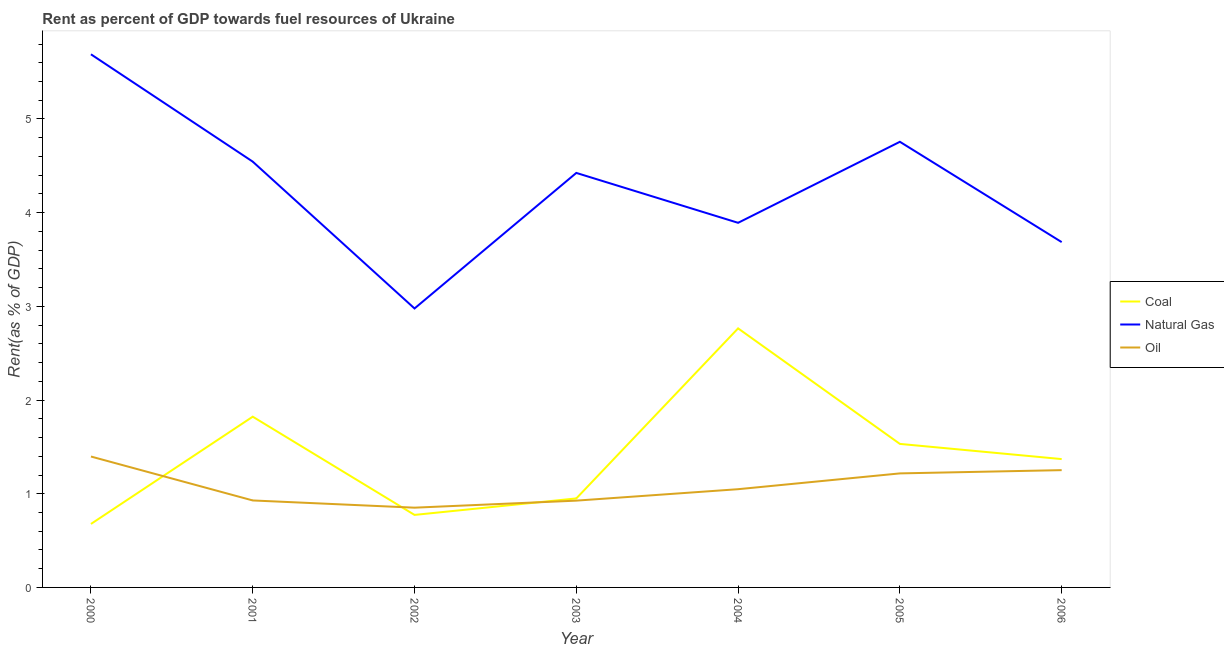How many different coloured lines are there?
Offer a terse response. 3. Does the line corresponding to rent towards coal intersect with the line corresponding to rent towards oil?
Make the answer very short. Yes. Is the number of lines equal to the number of legend labels?
Your answer should be compact. Yes. What is the rent towards oil in 2004?
Offer a very short reply. 1.05. Across all years, what is the maximum rent towards coal?
Your response must be concise. 2.77. Across all years, what is the minimum rent towards natural gas?
Offer a terse response. 2.98. In which year was the rent towards natural gas maximum?
Ensure brevity in your answer.  2000. In which year was the rent towards coal minimum?
Your response must be concise. 2000. What is the total rent towards coal in the graph?
Offer a terse response. 9.89. What is the difference between the rent towards oil in 2001 and that in 2003?
Ensure brevity in your answer.  0. What is the difference between the rent towards natural gas in 2005 and the rent towards coal in 2001?
Give a very brief answer. 2.93. What is the average rent towards coal per year?
Your response must be concise. 1.41. In the year 2004, what is the difference between the rent towards oil and rent towards natural gas?
Provide a succinct answer. -2.84. In how many years, is the rent towards oil greater than 2 %?
Your answer should be compact. 0. What is the ratio of the rent towards coal in 2002 to that in 2003?
Offer a terse response. 0.81. Is the rent towards oil in 2001 less than that in 2003?
Make the answer very short. No. What is the difference between the highest and the second highest rent towards coal?
Your response must be concise. 0.94. What is the difference between the highest and the lowest rent towards natural gas?
Ensure brevity in your answer.  2.71. Is the sum of the rent towards oil in 2004 and 2006 greater than the maximum rent towards natural gas across all years?
Give a very brief answer. No. Is the rent towards coal strictly greater than the rent towards natural gas over the years?
Ensure brevity in your answer.  No. Is the rent towards oil strictly less than the rent towards coal over the years?
Provide a succinct answer. No. What is the difference between two consecutive major ticks on the Y-axis?
Give a very brief answer. 1. Does the graph contain any zero values?
Ensure brevity in your answer.  No. Does the graph contain grids?
Your answer should be compact. No. Where does the legend appear in the graph?
Ensure brevity in your answer.  Center right. How many legend labels are there?
Offer a terse response. 3. What is the title of the graph?
Offer a very short reply. Rent as percent of GDP towards fuel resources of Ukraine. What is the label or title of the Y-axis?
Provide a short and direct response. Rent(as % of GDP). What is the Rent(as % of GDP) in Coal in 2000?
Provide a short and direct response. 0.68. What is the Rent(as % of GDP) in Natural Gas in 2000?
Offer a terse response. 5.69. What is the Rent(as % of GDP) of Oil in 2000?
Give a very brief answer. 1.4. What is the Rent(as % of GDP) in Coal in 2001?
Provide a succinct answer. 1.82. What is the Rent(as % of GDP) of Natural Gas in 2001?
Your answer should be very brief. 4.54. What is the Rent(as % of GDP) in Oil in 2001?
Provide a succinct answer. 0.93. What is the Rent(as % of GDP) in Coal in 2002?
Your response must be concise. 0.77. What is the Rent(as % of GDP) of Natural Gas in 2002?
Provide a short and direct response. 2.98. What is the Rent(as % of GDP) of Oil in 2002?
Make the answer very short. 0.85. What is the Rent(as % of GDP) of Coal in 2003?
Make the answer very short. 0.95. What is the Rent(as % of GDP) in Natural Gas in 2003?
Ensure brevity in your answer.  4.42. What is the Rent(as % of GDP) in Oil in 2003?
Offer a terse response. 0.93. What is the Rent(as % of GDP) of Coal in 2004?
Provide a succinct answer. 2.77. What is the Rent(as % of GDP) in Natural Gas in 2004?
Your answer should be compact. 3.89. What is the Rent(as % of GDP) of Oil in 2004?
Make the answer very short. 1.05. What is the Rent(as % of GDP) in Coal in 2005?
Your answer should be compact. 1.53. What is the Rent(as % of GDP) of Natural Gas in 2005?
Your answer should be compact. 4.76. What is the Rent(as % of GDP) of Oil in 2005?
Provide a succinct answer. 1.22. What is the Rent(as % of GDP) of Coal in 2006?
Your answer should be compact. 1.37. What is the Rent(as % of GDP) of Natural Gas in 2006?
Offer a very short reply. 3.69. What is the Rent(as % of GDP) of Oil in 2006?
Your answer should be compact. 1.25. Across all years, what is the maximum Rent(as % of GDP) of Coal?
Offer a terse response. 2.77. Across all years, what is the maximum Rent(as % of GDP) of Natural Gas?
Give a very brief answer. 5.69. Across all years, what is the maximum Rent(as % of GDP) of Oil?
Your response must be concise. 1.4. Across all years, what is the minimum Rent(as % of GDP) in Coal?
Offer a very short reply. 0.68. Across all years, what is the minimum Rent(as % of GDP) in Natural Gas?
Your answer should be compact. 2.98. Across all years, what is the minimum Rent(as % of GDP) in Oil?
Keep it short and to the point. 0.85. What is the total Rent(as % of GDP) of Coal in the graph?
Your answer should be compact. 9.89. What is the total Rent(as % of GDP) in Natural Gas in the graph?
Provide a succinct answer. 29.97. What is the total Rent(as % of GDP) in Oil in the graph?
Ensure brevity in your answer.  7.62. What is the difference between the Rent(as % of GDP) in Coal in 2000 and that in 2001?
Make the answer very short. -1.15. What is the difference between the Rent(as % of GDP) of Natural Gas in 2000 and that in 2001?
Your answer should be compact. 1.15. What is the difference between the Rent(as % of GDP) in Oil in 2000 and that in 2001?
Offer a very short reply. 0.47. What is the difference between the Rent(as % of GDP) in Coal in 2000 and that in 2002?
Keep it short and to the point. -0.1. What is the difference between the Rent(as % of GDP) in Natural Gas in 2000 and that in 2002?
Your answer should be very brief. 2.71. What is the difference between the Rent(as % of GDP) of Oil in 2000 and that in 2002?
Keep it short and to the point. 0.55. What is the difference between the Rent(as % of GDP) in Coal in 2000 and that in 2003?
Ensure brevity in your answer.  -0.27. What is the difference between the Rent(as % of GDP) in Natural Gas in 2000 and that in 2003?
Provide a succinct answer. 1.27. What is the difference between the Rent(as % of GDP) of Oil in 2000 and that in 2003?
Keep it short and to the point. 0.47. What is the difference between the Rent(as % of GDP) in Coal in 2000 and that in 2004?
Make the answer very short. -2.09. What is the difference between the Rent(as % of GDP) in Natural Gas in 2000 and that in 2004?
Give a very brief answer. 1.8. What is the difference between the Rent(as % of GDP) of Oil in 2000 and that in 2004?
Your answer should be very brief. 0.35. What is the difference between the Rent(as % of GDP) of Coal in 2000 and that in 2005?
Your answer should be compact. -0.85. What is the difference between the Rent(as % of GDP) of Natural Gas in 2000 and that in 2005?
Your answer should be compact. 0.93. What is the difference between the Rent(as % of GDP) in Oil in 2000 and that in 2005?
Offer a terse response. 0.18. What is the difference between the Rent(as % of GDP) in Coal in 2000 and that in 2006?
Your answer should be compact. -0.69. What is the difference between the Rent(as % of GDP) in Natural Gas in 2000 and that in 2006?
Offer a terse response. 2. What is the difference between the Rent(as % of GDP) of Oil in 2000 and that in 2006?
Offer a terse response. 0.15. What is the difference between the Rent(as % of GDP) of Coal in 2001 and that in 2002?
Ensure brevity in your answer.  1.05. What is the difference between the Rent(as % of GDP) in Natural Gas in 2001 and that in 2002?
Your answer should be compact. 1.57. What is the difference between the Rent(as % of GDP) of Oil in 2001 and that in 2002?
Offer a terse response. 0.08. What is the difference between the Rent(as % of GDP) in Coal in 2001 and that in 2003?
Make the answer very short. 0.87. What is the difference between the Rent(as % of GDP) in Natural Gas in 2001 and that in 2003?
Your response must be concise. 0.12. What is the difference between the Rent(as % of GDP) of Oil in 2001 and that in 2003?
Ensure brevity in your answer.  0. What is the difference between the Rent(as % of GDP) of Coal in 2001 and that in 2004?
Provide a short and direct response. -0.94. What is the difference between the Rent(as % of GDP) of Natural Gas in 2001 and that in 2004?
Offer a very short reply. 0.65. What is the difference between the Rent(as % of GDP) in Oil in 2001 and that in 2004?
Give a very brief answer. -0.12. What is the difference between the Rent(as % of GDP) in Coal in 2001 and that in 2005?
Your answer should be very brief. 0.29. What is the difference between the Rent(as % of GDP) in Natural Gas in 2001 and that in 2005?
Your answer should be very brief. -0.21. What is the difference between the Rent(as % of GDP) in Oil in 2001 and that in 2005?
Offer a terse response. -0.29. What is the difference between the Rent(as % of GDP) in Coal in 2001 and that in 2006?
Your response must be concise. 0.45. What is the difference between the Rent(as % of GDP) in Natural Gas in 2001 and that in 2006?
Keep it short and to the point. 0.86. What is the difference between the Rent(as % of GDP) of Oil in 2001 and that in 2006?
Give a very brief answer. -0.32. What is the difference between the Rent(as % of GDP) in Coal in 2002 and that in 2003?
Provide a succinct answer. -0.18. What is the difference between the Rent(as % of GDP) of Natural Gas in 2002 and that in 2003?
Provide a short and direct response. -1.45. What is the difference between the Rent(as % of GDP) of Oil in 2002 and that in 2003?
Your response must be concise. -0.08. What is the difference between the Rent(as % of GDP) in Coal in 2002 and that in 2004?
Your answer should be very brief. -1.99. What is the difference between the Rent(as % of GDP) in Natural Gas in 2002 and that in 2004?
Provide a short and direct response. -0.91. What is the difference between the Rent(as % of GDP) of Oil in 2002 and that in 2004?
Your answer should be compact. -0.2. What is the difference between the Rent(as % of GDP) in Coal in 2002 and that in 2005?
Ensure brevity in your answer.  -0.76. What is the difference between the Rent(as % of GDP) in Natural Gas in 2002 and that in 2005?
Your answer should be compact. -1.78. What is the difference between the Rent(as % of GDP) in Oil in 2002 and that in 2005?
Your answer should be very brief. -0.37. What is the difference between the Rent(as % of GDP) of Coal in 2002 and that in 2006?
Your response must be concise. -0.6. What is the difference between the Rent(as % of GDP) of Natural Gas in 2002 and that in 2006?
Your answer should be very brief. -0.71. What is the difference between the Rent(as % of GDP) in Oil in 2002 and that in 2006?
Give a very brief answer. -0.4. What is the difference between the Rent(as % of GDP) of Coal in 2003 and that in 2004?
Provide a succinct answer. -1.81. What is the difference between the Rent(as % of GDP) in Natural Gas in 2003 and that in 2004?
Your answer should be very brief. 0.53. What is the difference between the Rent(as % of GDP) in Oil in 2003 and that in 2004?
Offer a terse response. -0.12. What is the difference between the Rent(as % of GDP) of Coal in 2003 and that in 2005?
Your answer should be very brief. -0.58. What is the difference between the Rent(as % of GDP) in Natural Gas in 2003 and that in 2005?
Keep it short and to the point. -0.33. What is the difference between the Rent(as % of GDP) in Oil in 2003 and that in 2005?
Provide a succinct answer. -0.29. What is the difference between the Rent(as % of GDP) in Coal in 2003 and that in 2006?
Offer a terse response. -0.42. What is the difference between the Rent(as % of GDP) in Natural Gas in 2003 and that in 2006?
Your response must be concise. 0.74. What is the difference between the Rent(as % of GDP) of Oil in 2003 and that in 2006?
Provide a short and direct response. -0.33. What is the difference between the Rent(as % of GDP) in Coal in 2004 and that in 2005?
Make the answer very short. 1.23. What is the difference between the Rent(as % of GDP) of Natural Gas in 2004 and that in 2005?
Offer a terse response. -0.86. What is the difference between the Rent(as % of GDP) in Oil in 2004 and that in 2005?
Your answer should be very brief. -0.17. What is the difference between the Rent(as % of GDP) of Coal in 2004 and that in 2006?
Ensure brevity in your answer.  1.4. What is the difference between the Rent(as % of GDP) of Natural Gas in 2004 and that in 2006?
Provide a succinct answer. 0.21. What is the difference between the Rent(as % of GDP) of Oil in 2004 and that in 2006?
Offer a very short reply. -0.2. What is the difference between the Rent(as % of GDP) of Coal in 2005 and that in 2006?
Offer a terse response. 0.16. What is the difference between the Rent(as % of GDP) in Natural Gas in 2005 and that in 2006?
Your response must be concise. 1.07. What is the difference between the Rent(as % of GDP) in Oil in 2005 and that in 2006?
Provide a succinct answer. -0.03. What is the difference between the Rent(as % of GDP) in Coal in 2000 and the Rent(as % of GDP) in Natural Gas in 2001?
Your answer should be very brief. -3.87. What is the difference between the Rent(as % of GDP) in Coal in 2000 and the Rent(as % of GDP) in Oil in 2001?
Your answer should be compact. -0.25. What is the difference between the Rent(as % of GDP) of Natural Gas in 2000 and the Rent(as % of GDP) of Oil in 2001?
Your answer should be compact. 4.76. What is the difference between the Rent(as % of GDP) in Coal in 2000 and the Rent(as % of GDP) in Natural Gas in 2002?
Your answer should be very brief. -2.3. What is the difference between the Rent(as % of GDP) of Coal in 2000 and the Rent(as % of GDP) of Oil in 2002?
Provide a succinct answer. -0.17. What is the difference between the Rent(as % of GDP) of Natural Gas in 2000 and the Rent(as % of GDP) of Oil in 2002?
Ensure brevity in your answer.  4.84. What is the difference between the Rent(as % of GDP) of Coal in 2000 and the Rent(as % of GDP) of Natural Gas in 2003?
Your response must be concise. -3.75. What is the difference between the Rent(as % of GDP) of Coal in 2000 and the Rent(as % of GDP) of Oil in 2003?
Your response must be concise. -0.25. What is the difference between the Rent(as % of GDP) in Natural Gas in 2000 and the Rent(as % of GDP) in Oil in 2003?
Offer a terse response. 4.76. What is the difference between the Rent(as % of GDP) of Coal in 2000 and the Rent(as % of GDP) of Natural Gas in 2004?
Your answer should be very brief. -3.21. What is the difference between the Rent(as % of GDP) of Coal in 2000 and the Rent(as % of GDP) of Oil in 2004?
Keep it short and to the point. -0.37. What is the difference between the Rent(as % of GDP) in Natural Gas in 2000 and the Rent(as % of GDP) in Oil in 2004?
Your answer should be compact. 4.64. What is the difference between the Rent(as % of GDP) in Coal in 2000 and the Rent(as % of GDP) in Natural Gas in 2005?
Make the answer very short. -4.08. What is the difference between the Rent(as % of GDP) of Coal in 2000 and the Rent(as % of GDP) of Oil in 2005?
Make the answer very short. -0.54. What is the difference between the Rent(as % of GDP) of Natural Gas in 2000 and the Rent(as % of GDP) of Oil in 2005?
Provide a succinct answer. 4.47. What is the difference between the Rent(as % of GDP) in Coal in 2000 and the Rent(as % of GDP) in Natural Gas in 2006?
Your response must be concise. -3.01. What is the difference between the Rent(as % of GDP) of Coal in 2000 and the Rent(as % of GDP) of Oil in 2006?
Offer a very short reply. -0.57. What is the difference between the Rent(as % of GDP) of Natural Gas in 2000 and the Rent(as % of GDP) of Oil in 2006?
Give a very brief answer. 4.44. What is the difference between the Rent(as % of GDP) of Coal in 2001 and the Rent(as % of GDP) of Natural Gas in 2002?
Make the answer very short. -1.16. What is the difference between the Rent(as % of GDP) in Coal in 2001 and the Rent(as % of GDP) in Oil in 2002?
Provide a short and direct response. 0.97. What is the difference between the Rent(as % of GDP) of Natural Gas in 2001 and the Rent(as % of GDP) of Oil in 2002?
Your response must be concise. 3.69. What is the difference between the Rent(as % of GDP) of Coal in 2001 and the Rent(as % of GDP) of Natural Gas in 2003?
Your answer should be compact. -2.6. What is the difference between the Rent(as % of GDP) in Coal in 2001 and the Rent(as % of GDP) in Oil in 2003?
Your answer should be compact. 0.9. What is the difference between the Rent(as % of GDP) in Natural Gas in 2001 and the Rent(as % of GDP) in Oil in 2003?
Provide a short and direct response. 3.62. What is the difference between the Rent(as % of GDP) of Coal in 2001 and the Rent(as % of GDP) of Natural Gas in 2004?
Give a very brief answer. -2.07. What is the difference between the Rent(as % of GDP) of Coal in 2001 and the Rent(as % of GDP) of Oil in 2004?
Ensure brevity in your answer.  0.77. What is the difference between the Rent(as % of GDP) in Natural Gas in 2001 and the Rent(as % of GDP) in Oil in 2004?
Offer a terse response. 3.5. What is the difference between the Rent(as % of GDP) of Coal in 2001 and the Rent(as % of GDP) of Natural Gas in 2005?
Offer a very short reply. -2.93. What is the difference between the Rent(as % of GDP) in Coal in 2001 and the Rent(as % of GDP) in Oil in 2005?
Provide a short and direct response. 0.61. What is the difference between the Rent(as % of GDP) in Natural Gas in 2001 and the Rent(as % of GDP) in Oil in 2005?
Provide a short and direct response. 3.33. What is the difference between the Rent(as % of GDP) of Coal in 2001 and the Rent(as % of GDP) of Natural Gas in 2006?
Ensure brevity in your answer.  -1.86. What is the difference between the Rent(as % of GDP) in Coal in 2001 and the Rent(as % of GDP) in Oil in 2006?
Offer a terse response. 0.57. What is the difference between the Rent(as % of GDP) of Natural Gas in 2001 and the Rent(as % of GDP) of Oil in 2006?
Ensure brevity in your answer.  3.29. What is the difference between the Rent(as % of GDP) in Coal in 2002 and the Rent(as % of GDP) in Natural Gas in 2003?
Give a very brief answer. -3.65. What is the difference between the Rent(as % of GDP) in Coal in 2002 and the Rent(as % of GDP) in Oil in 2003?
Offer a terse response. -0.15. What is the difference between the Rent(as % of GDP) of Natural Gas in 2002 and the Rent(as % of GDP) of Oil in 2003?
Your answer should be very brief. 2.05. What is the difference between the Rent(as % of GDP) in Coal in 2002 and the Rent(as % of GDP) in Natural Gas in 2004?
Provide a succinct answer. -3.12. What is the difference between the Rent(as % of GDP) in Coal in 2002 and the Rent(as % of GDP) in Oil in 2004?
Your response must be concise. -0.27. What is the difference between the Rent(as % of GDP) of Natural Gas in 2002 and the Rent(as % of GDP) of Oil in 2004?
Ensure brevity in your answer.  1.93. What is the difference between the Rent(as % of GDP) in Coal in 2002 and the Rent(as % of GDP) in Natural Gas in 2005?
Offer a very short reply. -3.98. What is the difference between the Rent(as % of GDP) in Coal in 2002 and the Rent(as % of GDP) in Oil in 2005?
Your response must be concise. -0.44. What is the difference between the Rent(as % of GDP) of Natural Gas in 2002 and the Rent(as % of GDP) of Oil in 2005?
Offer a very short reply. 1.76. What is the difference between the Rent(as % of GDP) in Coal in 2002 and the Rent(as % of GDP) in Natural Gas in 2006?
Keep it short and to the point. -2.91. What is the difference between the Rent(as % of GDP) in Coal in 2002 and the Rent(as % of GDP) in Oil in 2006?
Keep it short and to the point. -0.48. What is the difference between the Rent(as % of GDP) in Natural Gas in 2002 and the Rent(as % of GDP) in Oil in 2006?
Give a very brief answer. 1.73. What is the difference between the Rent(as % of GDP) of Coal in 2003 and the Rent(as % of GDP) of Natural Gas in 2004?
Offer a terse response. -2.94. What is the difference between the Rent(as % of GDP) in Coal in 2003 and the Rent(as % of GDP) in Oil in 2004?
Provide a short and direct response. -0.1. What is the difference between the Rent(as % of GDP) in Natural Gas in 2003 and the Rent(as % of GDP) in Oil in 2004?
Give a very brief answer. 3.38. What is the difference between the Rent(as % of GDP) of Coal in 2003 and the Rent(as % of GDP) of Natural Gas in 2005?
Your answer should be very brief. -3.81. What is the difference between the Rent(as % of GDP) of Coal in 2003 and the Rent(as % of GDP) of Oil in 2005?
Offer a terse response. -0.27. What is the difference between the Rent(as % of GDP) of Natural Gas in 2003 and the Rent(as % of GDP) of Oil in 2005?
Your answer should be very brief. 3.21. What is the difference between the Rent(as % of GDP) of Coal in 2003 and the Rent(as % of GDP) of Natural Gas in 2006?
Your response must be concise. -2.74. What is the difference between the Rent(as % of GDP) in Coal in 2003 and the Rent(as % of GDP) in Oil in 2006?
Ensure brevity in your answer.  -0.3. What is the difference between the Rent(as % of GDP) of Natural Gas in 2003 and the Rent(as % of GDP) of Oil in 2006?
Your answer should be compact. 3.17. What is the difference between the Rent(as % of GDP) of Coal in 2004 and the Rent(as % of GDP) of Natural Gas in 2005?
Make the answer very short. -1.99. What is the difference between the Rent(as % of GDP) of Coal in 2004 and the Rent(as % of GDP) of Oil in 2005?
Give a very brief answer. 1.55. What is the difference between the Rent(as % of GDP) of Natural Gas in 2004 and the Rent(as % of GDP) of Oil in 2005?
Provide a short and direct response. 2.67. What is the difference between the Rent(as % of GDP) in Coal in 2004 and the Rent(as % of GDP) in Natural Gas in 2006?
Your response must be concise. -0.92. What is the difference between the Rent(as % of GDP) of Coal in 2004 and the Rent(as % of GDP) of Oil in 2006?
Provide a short and direct response. 1.51. What is the difference between the Rent(as % of GDP) in Natural Gas in 2004 and the Rent(as % of GDP) in Oil in 2006?
Make the answer very short. 2.64. What is the difference between the Rent(as % of GDP) in Coal in 2005 and the Rent(as % of GDP) in Natural Gas in 2006?
Ensure brevity in your answer.  -2.15. What is the difference between the Rent(as % of GDP) in Coal in 2005 and the Rent(as % of GDP) in Oil in 2006?
Your answer should be very brief. 0.28. What is the difference between the Rent(as % of GDP) in Natural Gas in 2005 and the Rent(as % of GDP) in Oil in 2006?
Provide a short and direct response. 3.5. What is the average Rent(as % of GDP) of Coal per year?
Your answer should be very brief. 1.41. What is the average Rent(as % of GDP) in Natural Gas per year?
Keep it short and to the point. 4.28. What is the average Rent(as % of GDP) in Oil per year?
Ensure brevity in your answer.  1.09. In the year 2000, what is the difference between the Rent(as % of GDP) in Coal and Rent(as % of GDP) in Natural Gas?
Your response must be concise. -5.01. In the year 2000, what is the difference between the Rent(as % of GDP) in Coal and Rent(as % of GDP) in Oil?
Give a very brief answer. -0.72. In the year 2000, what is the difference between the Rent(as % of GDP) in Natural Gas and Rent(as % of GDP) in Oil?
Provide a short and direct response. 4.29. In the year 2001, what is the difference between the Rent(as % of GDP) of Coal and Rent(as % of GDP) of Natural Gas?
Provide a short and direct response. -2.72. In the year 2001, what is the difference between the Rent(as % of GDP) of Coal and Rent(as % of GDP) of Oil?
Your answer should be compact. 0.89. In the year 2001, what is the difference between the Rent(as % of GDP) in Natural Gas and Rent(as % of GDP) in Oil?
Offer a terse response. 3.62. In the year 2002, what is the difference between the Rent(as % of GDP) in Coal and Rent(as % of GDP) in Natural Gas?
Ensure brevity in your answer.  -2.2. In the year 2002, what is the difference between the Rent(as % of GDP) in Coal and Rent(as % of GDP) in Oil?
Give a very brief answer. -0.08. In the year 2002, what is the difference between the Rent(as % of GDP) in Natural Gas and Rent(as % of GDP) in Oil?
Offer a terse response. 2.13. In the year 2003, what is the difference between the Rent(as % of GDP) in Coal and Rent(as % of GDP) in Natural Gas?
Provide a short and direct response. -3.47. In the year 2003, what is the difference between the Rent(as % of GDP) in Coal and Rent(as % of GDP) in Oil?
Keep it short and to the point. 0.02. In the year 2003, what is the difference between the Rent(as % of GDP) of Natural Gas and Rent(as % of GDP) of Oil?
Make the answer very short. 3.5. In the year 2004, what is the difference between the Rent(as % of GDP) in Coal and Rent(as % of GDP) in Natural Gas?
Your answer should be very brief. -1.13. In the year 2004, what is the difference between the Rent(as % of GDP) in Coal and Rent(as % of GDP) in Oil?
Make the answer very short. 1.72. In the year 2004, what is the difference between the Rent(as % of GDP) in Natural Gas and Rent(as % of GDP) in Oil?
Ensure brevity in your answer.  2.84. In the year 2005, what is the difference between the Rent(as % of GDP) in Coal and Rent(as % of GDP) in Natural Gas?
Your response must be concise. -3.22. In the year 2005, what is the difference between the Rent(as % of GDP) of Coal and Rent(as % of GDP) of Oil?
Ensure brevity in your answer.  0.31. In the year 2005, what is the difference between the Rent(as % of GDP) of Natural Gas and Rent(as % of GDP) of Oil?
Provide a succinct answer. 3.54. In the year 2006, what is the difference between the Rent(as % of GDP) of Coal and Rent(as % of GDP) of Natural Gas?
Your answer should be compact. -2.32. In the year 2006, what is the difference between the Rent(as % of GDP) of Coal and Rent(as % of GDP) of Oil?
Ensure brevity in your answer.  0.12. In the year 2006, what is the difference between the Rent(as % of GDP) of Natural Gas and Rent(as % of GDP) of Oil?
Keep it short and to the point. 2.43. What is the ratio of the Rent(as % of GDP) of Coal in 2000 to that in 2001?
Provide a succinct answer. 0.37. What is the ratio of the Rent(as % of GDP) of Natural Gas in 2000 to that in 2001?
Give a very brief answer. 1.25. What is the ratio of the Rent(as % of GDP) in Oil in 2000 to that in 2001?
Your answer should be compact. 1.5. What is the ratio of the Rent(as % of GDP) in Coal in 2000 to that in 2002?
Your response must be concise. 0.88. What is the ratio of the Rent(as % of GDP) in Natural Gas in 2000 to that in 2002?
Your response must be concise. 1.91. What is the ratio of the Rent(as % of GDP) of Oil in 2000 to that in 2002?
Offer a terse response. 1.64. What is the ratio of the Rent(as % of GDP) in Coal in 2000 to that in 2003?
Your answer should be very brief. 0.71. What is the ratio of the Rent(as % of GDP) of Natural Gas in 2000 to that in 2003?
Give a very brief answer. 1.29. What is the ratio of the Rent(as % of GDP) of Oil in 2000 to that in 2003?
Your answer should be very brief. 1.51. What is the ratio of the Rent(as % of GDP) of Coal in 2000 to that in 2004?
Make the answer very short. 0.24. What is the ratio of the Rent(as % of GDP) in Natural Gas in 2000 to that in 2004?
Your answer should be very brief. 1.46. What is the ratio of the Rent(as % of GDP) of Oil in 2000 to that in 2004?
Your answer should be compact. 1.33. What is the ratio of the Rent(as % of GDP) of Coal in 2000 to that in 2005?
Keep it short and to the point. 0.44. What is the ratio of the Rent(as % of GDP) of Natural Gas in 2000 to that in 2005?
Your answer should be compact. 1.2. What is the ratio of the Rent(as % of GDP) of Oil in 2000 to that in 2005?
Your answer should be compact. 1.15. What is the ratio of the Rent(as % of GDP) in Coal in 2000 to that in 2006?
Offer a very short reply. 0.49. What is the ratio of the Rent(as % of GDP) in Natural Gas in 2000 to that in 2006?
Keep it short and to the point. 1.54. What is the ratio of the Rent(as % of GDP) of Oil in 2000 to that in 2006?
Make the answer very short. 1.12. What is the ratio of the Rent(as % of GDP) of Coal in 2001 to that in 2002?
Provide a succinct answer. 2.35. What is the ratio of the Rent(as % of GDP) in Natural Gas in 2001 to that in 2002?
Your answer should be very brief. 1.53. What is the ratio of the Rent(as % of GDP) of Oil in 2001 to that in 2002?
Offer a very short reply. 1.09. What is the ratio of the Rent(as % of GDP) of Coal in 2001 to that in 2003?
Provide a succinct answer. 1.92. What is the ratio of the Rent(as % of GDP) in Natural Gas in 2001 to that in 2003?
Your response must be concise. 1.03. What is the ratio of the Rent(as % of GDP) of Coal in 2001 to that in 2004?
Your answer should be very brief. 0.66. What is the ratio of the Rent(as % of GDP) in Natural Gas in 2001 to that in 2004?
Your answer should be very brief. 1.17. What is the ratio of the Rent(as % of GDP) in Oil in 2001 to that in 2004?
Give a very brief answer. 0.89. What is the ratio of the Rent(as % of GDP) of Coal in 2001 to that in 2005?
Your response must be concise. 1.19. What is the ratio of the Rent(as % of GDP) of Natural Gas in 2001 to that in 2005?
Ensure brevity in your answer.  0.96. What is the ratio of the Rent(as % of GDP) of Oil in 2001 to that in 2005?
Provide a succinct answer. 0.76. What is the ratio of the Rent(as % of GDP) in Coal in 2001 to that in 2006?
Make the answer very short. 1.33. What is the ratio of the Rent(as % of GDP) in Natural Gas in 2001 to that in 2006?
Provide a succinct answer. 1.23. What is the ratio of the Rent(as % of GDP) of Oil in 2001 to that in 2006?
Offer a very short reply. 0.74. What is the ratio of the Rent(as % of GDP) of Coal in 2002 to that in 2003?
Give a very brief answer. 0.81. What is the ratio of the Rent(as % of GDP) of Natural Gas in 2002 to that in 2003?
Make the answer very short. 0.67. What is the ratio of the Rent(as % of GDP) in Oil in 2002 to that in 2003?
Offer a terse response. 0.92. What is the ratio of the Rent(as % of GDP) of Coal in 2002 to that in 2004?
Your response must be concise. 0.28. What is the ratio of the Rent(as % of GDP) of Natural Gas in 2002 to that in 2004?
Provide a short and direct response. 0.77. What is the ratio of the Rent(as % of GDP) of Oil in 2002 to that in 2004?
Make the answer very short. 0.81. What is the ratio of the Rent(as % of GDP) in Coal in 2002 to that in 2005?
Keep it short and to the point. 0.51. What is the ratio of the Rent(as % of GDP) of Natural Gas in 2002 to that in 2005?
Your answer should be compact. 0.63. What is the ratio of the Rent(as % of GDP) of Oil in 2002 to that in 2005?
Ensure brevity in your answer.  0.7. What is the ratio of the Rent(as % of GDP) of Coal in 2002 to that in 2006?
Make the answer very short. 0.56. What is the ratio of the Rent(as % of GDP) of Natural Gas in 2002 to that in 2006?
Keep it short and to the point. 0.81. What is the ratio of the Rent(as % of GDP) in Oil in 2002 to that in 2006?
Your answer should be compact. 0.68. What is the ratio of the Rent(as % of GDP) in Coal in 2003 to that in 2004?
Ensure brevity in your answer.  0.34. What is the ratio of the Rent(as % of GDP) of Natural Gas in 2003 to that in 2004?
Your answer should be very brief. 1.14. What is the ratio of the Rent(as % of GDP) in Oil in 2003 to that in 2004?
Your answer should be very brief. 0.88. What is the ratio of the Rent(as % of GDP) of Coal in 2003 to that in 2005?
Your answer should be compact. 0.62. What is the ratio of the Rent(as % of GDP) of Natural Gas in 2003 to that in 2005?
Your answer should be compact. 0.93. What is the ratio of the Rent(as % of GDP) in Oil in 2003 to that in 2005?
Keep it short and to the point. 0.76. What is the ratio of the Rent(as % of GDP) of Coal in 2003 to that in 2006?
Make the answer very short. 0.69. What is the ratio of the Rent(as % of GDP) of Natural Gas in 2003 to that in 2006?
Keep it short and to the point. 1.2. What is the ratio of the Rent(as % of GDP) in Oil in 2003 to that in 2006?
Offer a terse response. 0.74. What is the ratio of the Rent(as % of GDP) of Coal in 2004 to that in 2005?
Your answer should be very brief. 1.8. What is the ratio of the Rent(as % of GDP) of Natural Gas in 2004 to that in 2005?
Give a very brief answer. 0.82. What is the ratio of the Rent(as % of GDP) of Oil in 2004 to that in 2005?
Your answer should be very brief. 0.86. What is the ratio of the Rent(as % of GDP) in Coal in 2004 to that in 2006?
Ensure brevity in your answer.  2.02. What is the ratio of the Rent(as % of GDP) of Natural Gas in 2004 to that in 2006?
Your answer should be very brief. 1.06. What is the ratio of the Rent(as % of GDP) in Oil in 2004 to that in 2006?
Provide a short and direct response. 0.84. What is the ratio of the Rent(as % of GDP) of Coal in 2005 to that in 2006?
Your answer should be very brief. 1.12. What is the ratio of the Rent(as % of GDP) in Natural Gas in 2005 to that in 2006?
Give a very brief answer. 1.29. What is the ratio of the Rent(as % of GDP) in Oil in 2005 to that in 2006?
Give a very brief answer. 0.97. What is the difference between the highest and the second highest Rent(as % of GDP) of Coal?
Offer a terse response. 0.94. What is the difference between the highest and the second highest Rent(as % of GDP) of Natural Gas?
Your answer should be compact. 0.93. What is the difference between the highest and the second highest Rent(as % of GDP) of Oil?
Your answer should be very brief. 0.15. What is the difference between the highest and the lowest Rent(as % of GDP) in Coal?
Make the answer very short. 2.09. What is the difference between the highest and the lowest Rent(as % of GDP) in Natural Gas?
Provide a succinct answer. 2.71. What is the difference between the highest and the lowest Rent(as % of GDP) of Oil?
Keep it short and to the point. 0.55. 